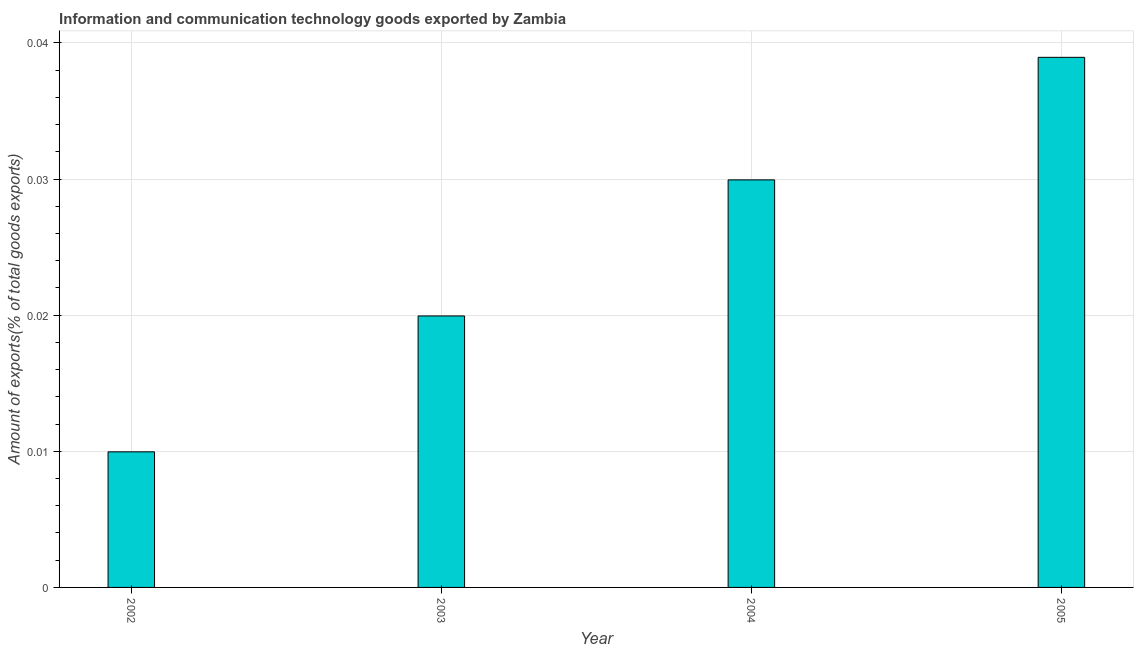What is the title of the graph?
Offer a very short reply. Information and communication technology goods exported by Zambia. What is the label or title of the X-axis?
Provide a short and direct response. Year. What is the label or title of the Y-axis?
Offer a very short reply. Amount of exports(% of total goods exports). What is the amount of ict goods exports in 2004?
Make the answer very short. 0.03. Across all years, what is the maximum amount of ict goods exports?
Give a very brief answer. 0.04. Across all years, what is the minimum amount of ict goods exports?
Ensure brevity in your answer.  0.01. In which year was the amount of ict goods exports minimum?
Ensure brevity in your answer.  2002. What is the sum of the amount of ict goods exports?
Make the answer very short. 0.1. What is the difference between the amount of ict goods exports in 2002 and 2003?
Your answer should be very brief. -0.01. What is the average amount of ict goods exports per year?
Your answer should be very brief. 0.03. What is the median amount of ict goods exports?
Your answer should be compact. 0.02. In how many years, is the amount of ict goods exports greater than 0.012 %?
Your answer should be very brief. 3. Do a majority of the years between 2003 and 2005 (inclusive) have amount of ict goods exports greater than 0.02 %?
Give a very brief answer. Yes. What is the ratio of the amount of ict goods exports in 2002 to that in 2005?
Provide a short and direct response. 0.26. Is the amount of ict goods exports in 2003 less than that in 2004?
Offer a very short reply. Yes. Is the difference between the amount of ict goods exports in 2002 and 2003 greater than the difference between any two years?
Your response must be concise. No. What is the difference between the highest and the second highest amount of ict goods exports?
Give a very brief answer. 0.01. Is the sum of the amount of ict goods exports in 2002 and 2003 greater than the maximum amount of ict goods exports across all years?
Give a very brief answer. No. In how many years, is the amount of ict goods exports greater than the average amount of ict goods exports taken over all years?
Your response must be concise. 2. Are all the bars in the graph horizontal?
Offer a very short reply. No. What is the Amount of exports(% of total goods exports) of 2002?
Offer a very short reply. 0.01. What is the Amount of exports(% of total goods exports) in 2003?
Your answer should be very brief. 0.02. What is the Amount of exports(% of total goods exports) in 2004?
Provide a succinct answer. 0.03. What is the Amount of exports(% of total goods exports) of 2005?
Provide a succinct answer. 0.04. What is the difference between the Amount of exports(% of total goods exports) in 2002 and 2003?
Ensure brevity in your answer.  -0.01. What is the difference between the Amount of exports(% of total goods exports) in 2002 and 2004?
Your answer should be compact. -0.02. What is the difference between the Amount of exports(% of total goods exports) in 2002 and 2005?
Offer a very short reply. -0.03. What is the difference between the Amount of exports(% of total goods exports) in 2003 and 2004?
Provide a short and direct response. -0.01. What is the difference between the Amount of exports(% of total goods exports) in 2003 and 2005?
Keep it short and to the point. -0.02. What is the difference between the Amount of exports(% of total goods exports) in 2004 and 2005?
Make the answer very short. -0.01. What is the ratio of the Amount of exports(% of total goods exports) in 2002 to that in 2003?
Give a very brief answer. 0.5. What is the ratio of the Amount of exports(% of total goods exports) in 2002 to that in 2004?
Make the answer very short. 0.33. What is the ratio of the Amount of exports(% of total goods exports) in 2002 to that in 2005?
Keep it short and to the point. 0.26. What is the ratio of the Amount of exports(% of total goods exports) in 2003 to that in 2004?
Provide a short and direct response. 0.67. What is the ratio of the Amount of exports(% of total goods exports) in 2003 to that in 2005?
Offer a terse response. 0.51. What is the ratio of the Amount of exports(% of total goods exports) in 2004 to that in 2005?
Your answer should be very brief. 0.77. 